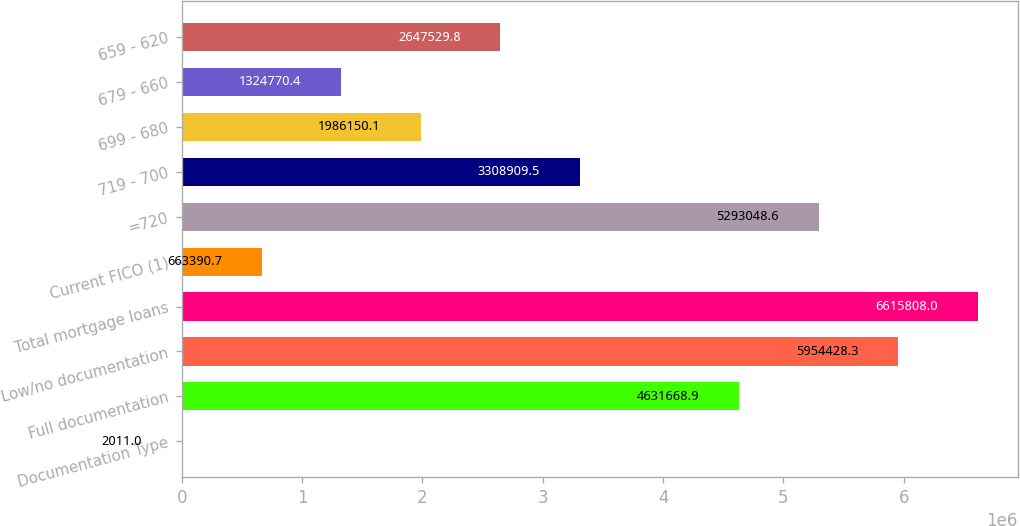Convert chart to OTSL. <chart><loc_0><loc_0><loc_500><loc_500><bar_chart><fcel>Documentation Type<fcel>Full documentation<fcel>Low/no documentation<fcel>Total mortgage loans<fcel>Current FICO (1)<fcel>=720<fcel>719 - 700<fcel>699 - 680<fcel>679 - 660<fcel>659 - 620<nl><fcel>2011<fcel>4.63167e+06<fcel>5.95443e+06<fcel>6.61581e+06<fcel>663391<fcel>5.29305e+06<fcel>3.30891e+06<fcel>1.98615e+06<fcel>1.32477e+06<fcel>2.64753e+06<nl></chart> 